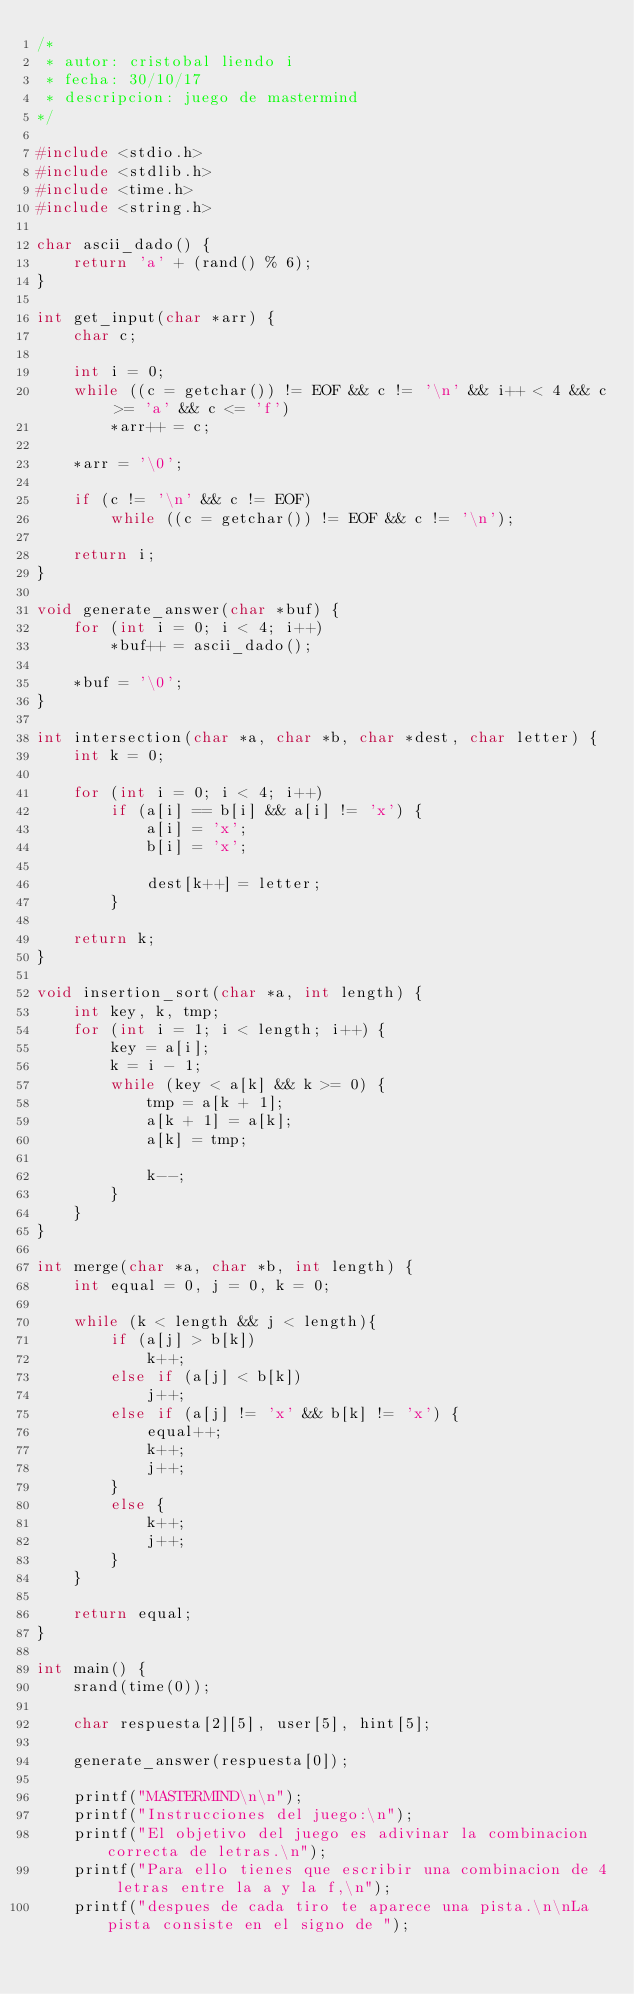<code> <loc_0><loc_0><loc_500><loc_500><_C_>/*
 * autor: cristobal liendo i
 * fecha: 30/10/17
 * descripcion: juego de mastermind
*/

#include <stdio.h>
#include <stdlib.h>
#include <time.h>
#include <string.h>

char ascii_dado() {
    return 'a' + (rand() % 6);
}

int get_input(char *arr) {
    char c;

    int i = 0;
    while ((c = getchar()) != EOF && c != '\n' && i++ < 4 && c >= 'a' && c <= 'f')
        *arr++ = c;

    *arr = '\0';

    if (c != '\n' && c != EOF)
        while ((c = getchar()) != EOF && c != '\n');

    return i;
}

void generate_answer(char *buf) {
    for (int i = 0; i < 4; i++)
        *buf++ = ascii_dado();

    *buf = '\0';
}

int intersection(char *a, char *b, char *dest, char letter) {
    int k = 0;

    for (int i = 0; i < 4; i++)
        if (a[i] == b[i] && a[i] != 'x') {
            a[i] = 'x';
            b[i] = 'x';

            dest[k++] = letter;
        }

    return k;
}

void insertion_sort(char *a, int length) {
    int key, k, tmp;
    for (int i = 1; i < length; i++) {
        key = a[i];
        k = i - 1;
        while (key < a[k] && k >= 0) {
            tmp = a[k + 1];
            a[k + 1] = a[k];
            a[k] = tmp;

            k--;
        }
    }
}

int merge(char *a, char *b, int length) {
    int equal = 0, j = 0, k = 0;

    while (k < length && j < length){
        if (a[j] > b[k])
            k++;
        else if (a[j] < b[k])
            j++;
        else if (a[j] != 'x' && b[k] != 'x') {
            equal++;
            k++;
            j++;
        }
        else {
            k++;
            j++;
        }
    }

    return equal;
}

int main() {
    srand(time(0));

    char respuesta[2][5], user[5], hint[5];

    generate_answer(respuesta[0]);

    printf("MASTERMIND\n\n");
    printf("Instrucciones del juego:\n");
    printf("El objetivo del juego es adivinar la combinacion correcta de letras.\n");
    printf("Para ello tienes que escribir una combinacion de 4 letras entre la a y la f,\n");
    printf("despues de cada tiro te aparece una pista.\n\nLa pista consiste en el signo de ");</code> 